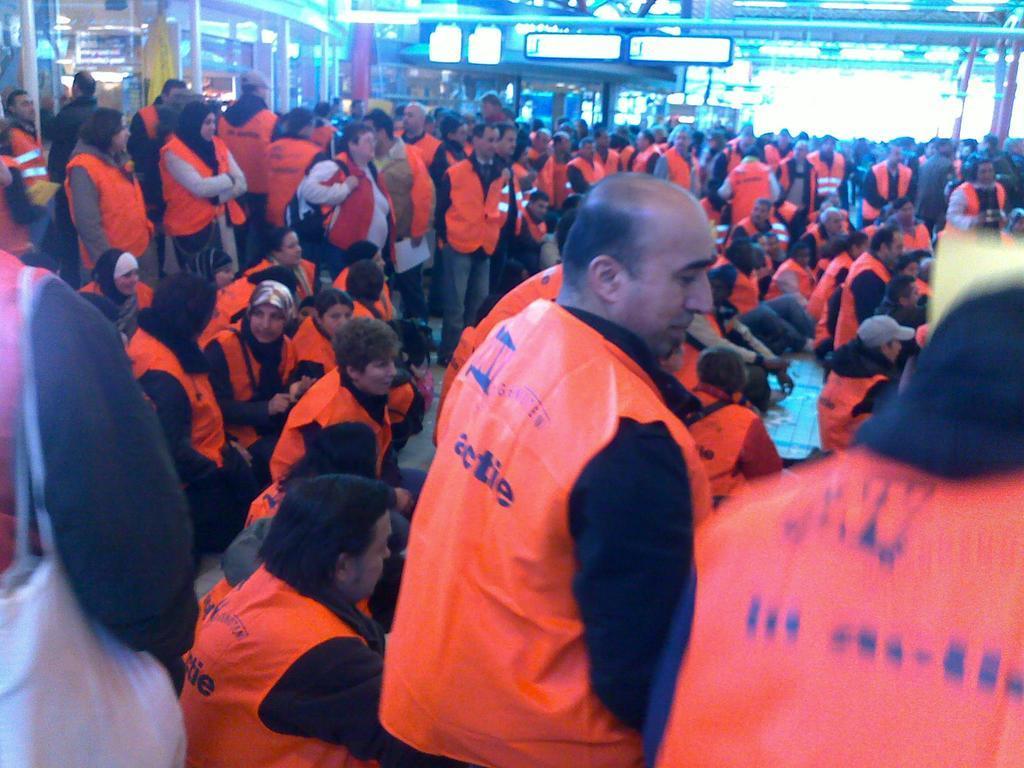Please provide a concise description of this image. In the image there are many people standing and sitting all over the place in safety jacket, it seems to be clicked inside a mall. 